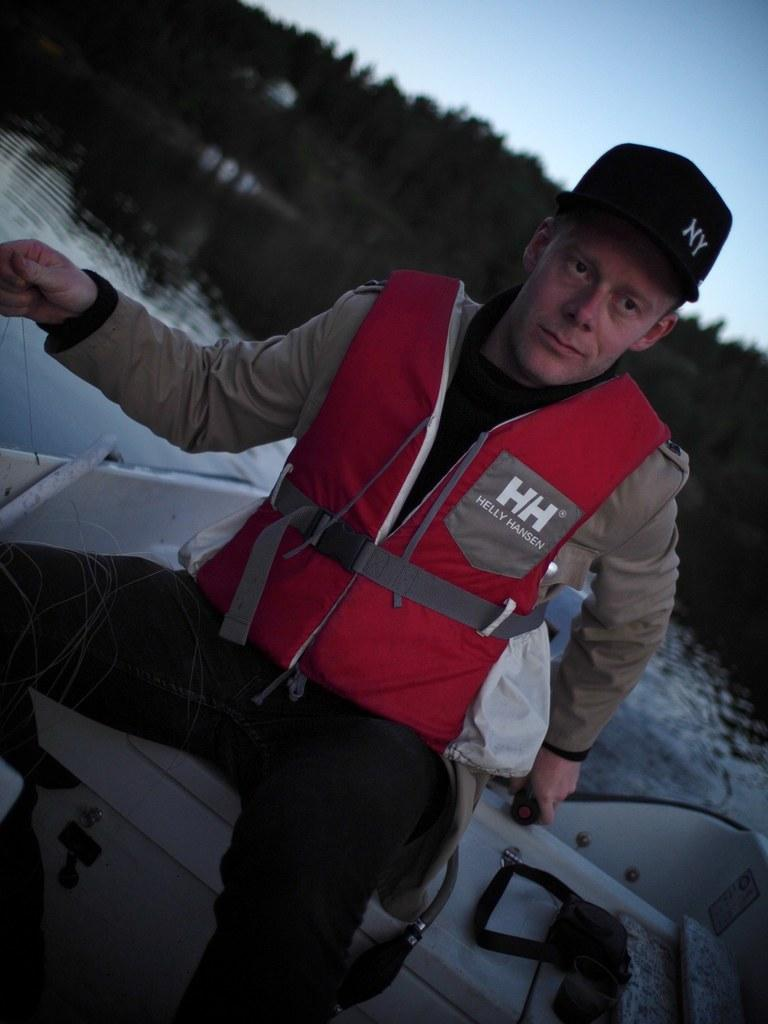What is the main subject of the image? The main subject of the image is a man. What is the man wearing in the image? The man is wearing a jacket in the image. Where is the man located in the image? The man is sitting on a boat in the image. What can be seen in the background of the image? There is water, trees, and the sky visible in the background of the image. What grade did the man receive on his recent exam in the image? There is no indication of an exam or grade in the image; it simply shows a man sitting on a boat. What type of current can be seen in the water in the image? There is no current visible in the water in the image; it is a still body of water. 